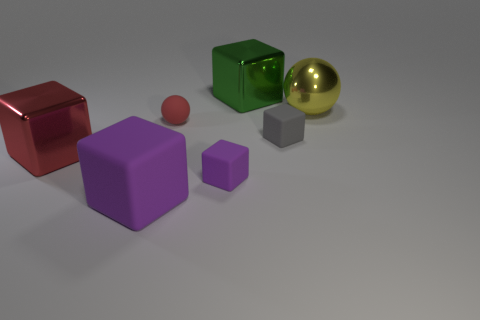Subtract all green cubes. How many cubes are left? 4 Subtract all small purple matte cubes. How many cubes are left? 4 Subtract all blue blocks. Subtract all gray cylinders. How many blocks are left? 5 Add 1 tiny spheres. How many objects exist? 8 Subtract all spheres. How many objects are left? 5 Add 6 matte blocks. How many matte blocks exist? 9 Subtract 0 brown cubes. How many objects are left? 7 Subtract all shiny balls. Subtract all large balls. How many objects are left? 5 Add 1 big metallic balls. How many big metallic balls are left? 2 